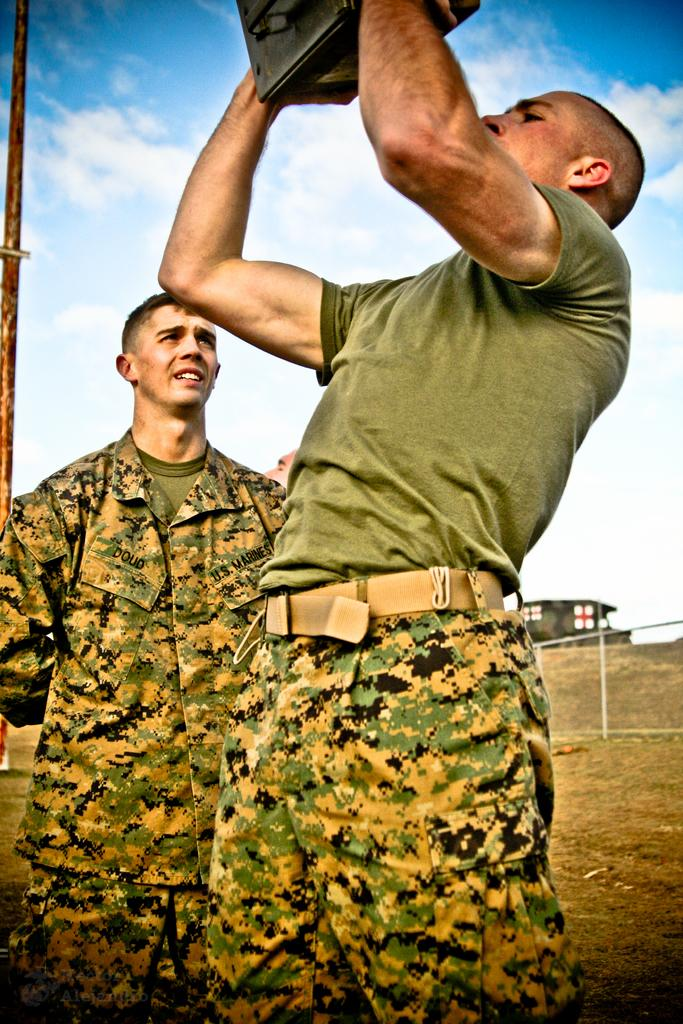What are the men in the image doing? The men in the image are standing. Can you describe what one of the men is holding? One man is holding a box. How is the man holding the box? The man is lifting the box with his hands. What can be seen in the image besides the men? There is a vehicle in the image. What is unique about the vehicle? The vehicle has flags on it. How would you describe the sky in the image? The sky is blue and cloudy in the image. What type of lip balm is the man applying in the image? There is no lip balm or any indication of the man applying anything in the image. 